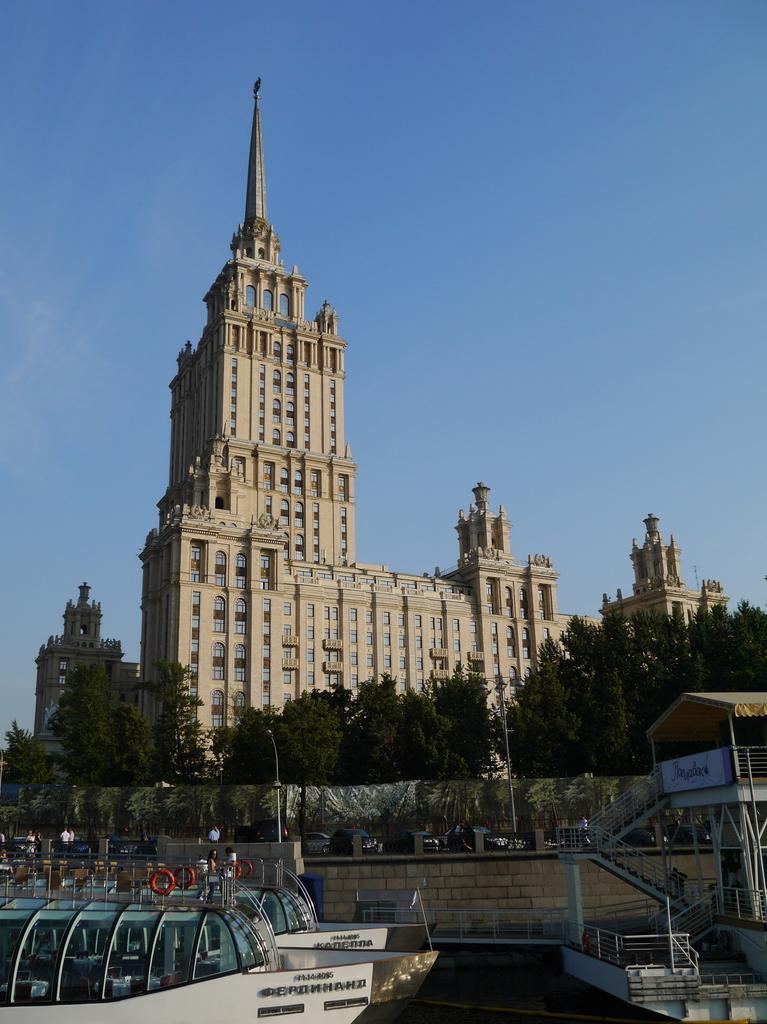What type of transportation can be seen in the image? There are boats and vehicles in the image. What architectural feature is present in the image? There is a staircase in the image. What object is present in the image that might be used for writing or displaying information? There is a board in the image. What might be used for support or guidance in the image? There are poles in the image. How many people are present in the image? There are people in the image. What can be seen in the background of the image? There are trees, buildings, and the sky visible in the background of the image. What type of wire is being used by the rat in the image? There is no rat or wire present in the image. What type of yoke is being used by the people in the image? There is no yoke present in the image; the people are not using any such object. 